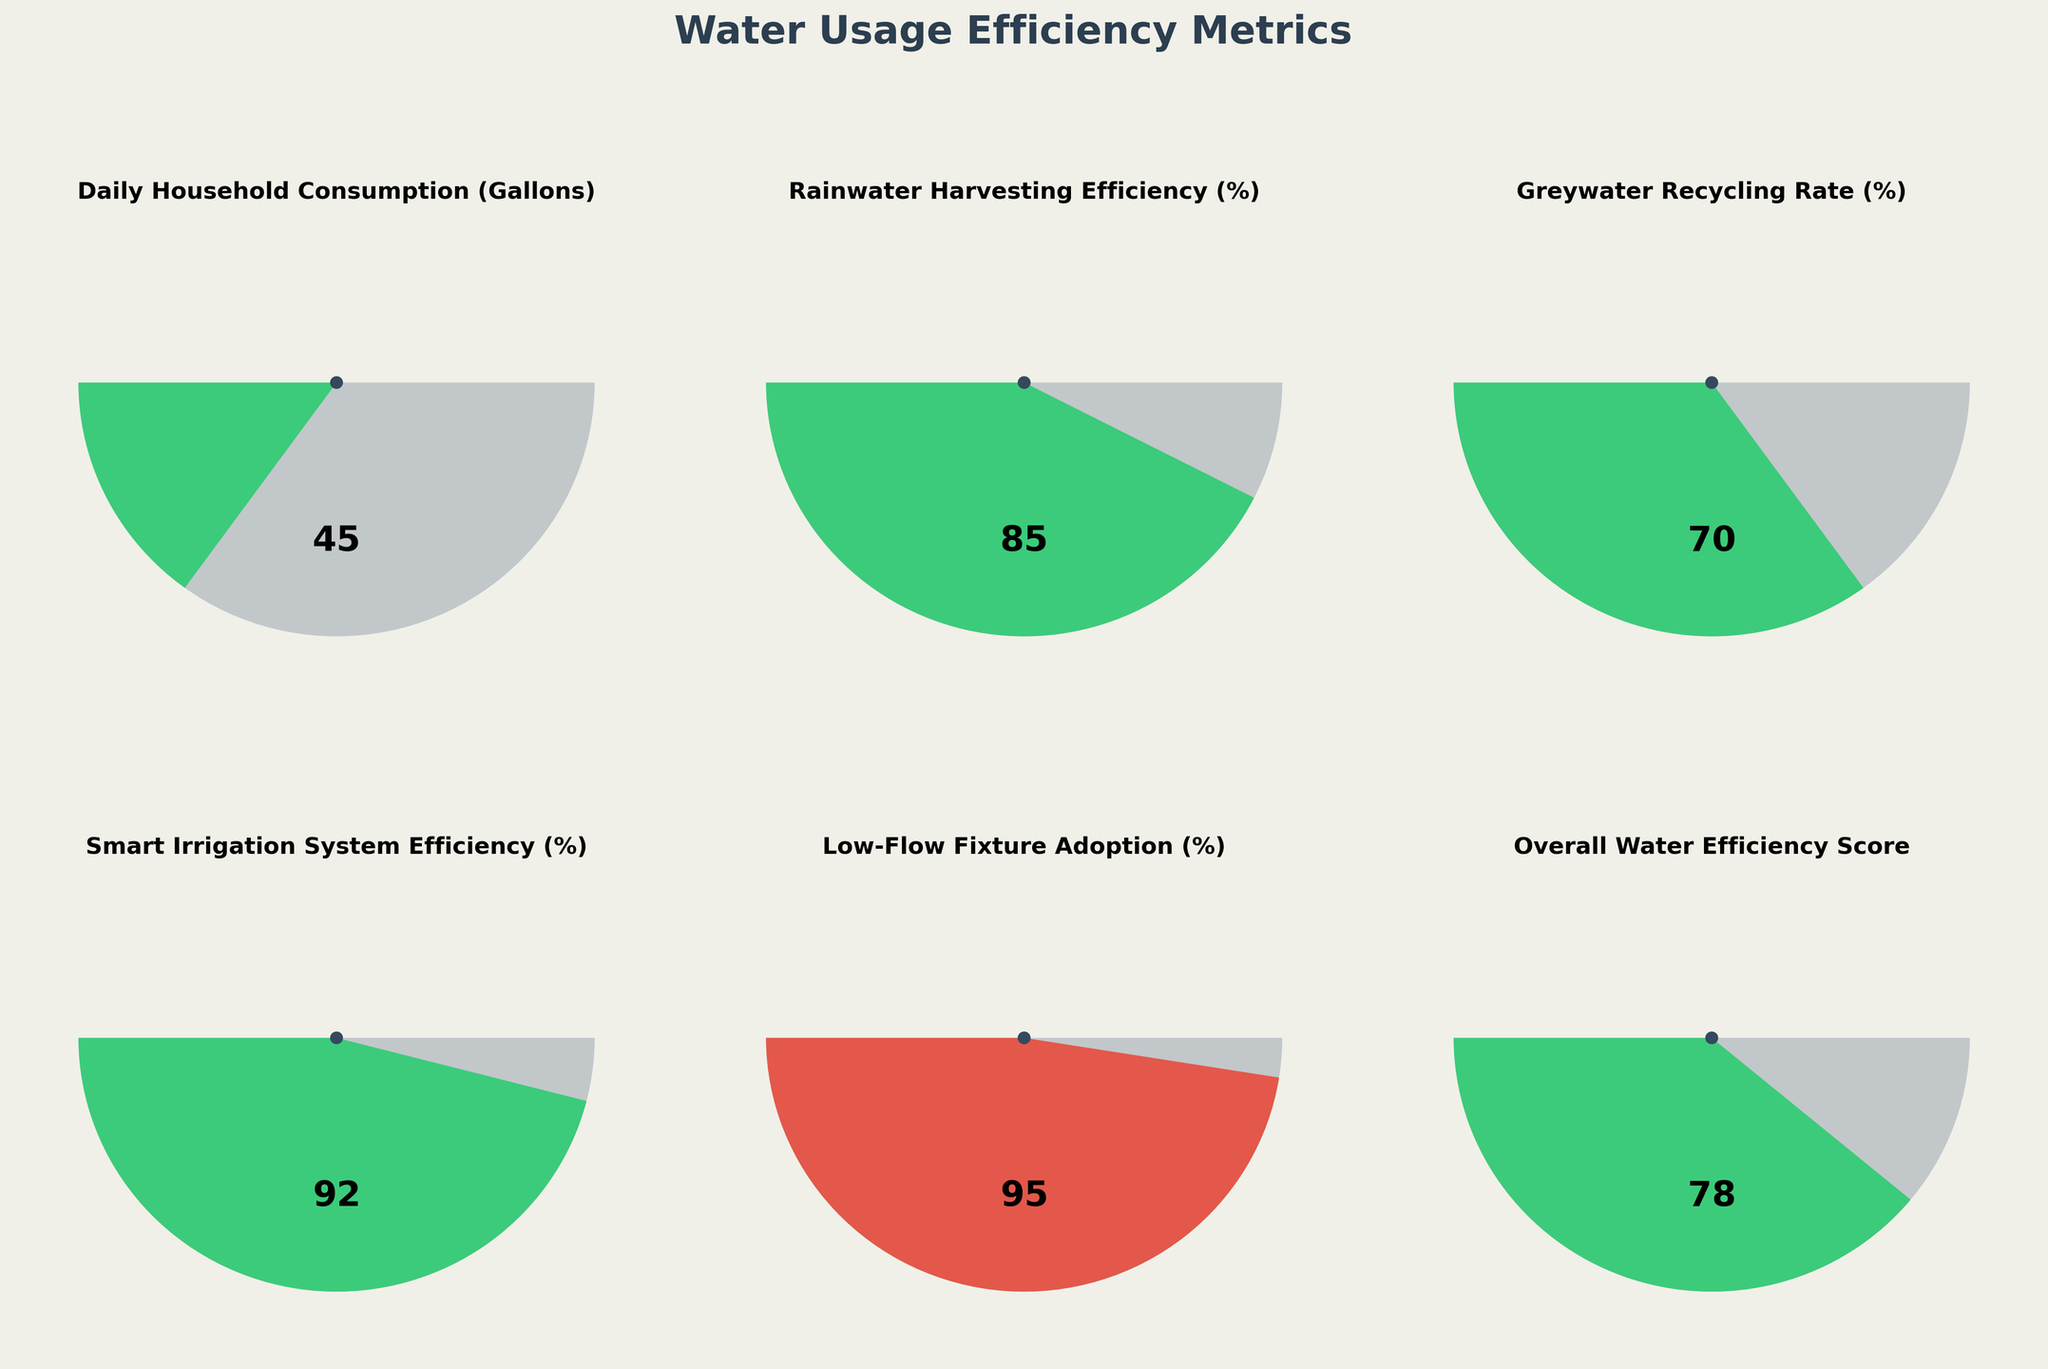What's the title of the figure? The title is mentioned at the top of the figure and reads "Water Usage Efficiency Metrics."
Answer: Water Usage Efficiency Metrics What is the current value for the daily household water consumption in gallons? The gauge for daily household water consumption is at the top-left of the figure, showing a current value of 45 gallons.
Answer: 45 gallons Does the smart irrigation system efficiency fall within the desired efficiency range? The smart irrigation system efficiency gauge shows a value of 92%, which is within the desired range of 75% to 95%, as indicated by the green color of the gauge.
Answer: Yes Which metric has the highest current value? Among all the gauges, Low-Flow Fixture Adoption shows the highest current value at 95%.
Answer: Low-Flow Fixture Adoption Compare the current value of greywater recycling rate to its low threshold. Is it above the threshold? The greywater recycling rate has a current value of 70%, which is above its low threshold of 50%.
Answer: Yes By how many percentage points is rainwater harvesting efficiency above its minimum value? Rainwater harvesting efficiency has a current value of 85% and a minimum value of 0%. The difference is 85% - 0% = 85 percentage points.
Answer: 85 percentage points Which of the efficiency metrics has the least deviation from its high threshold? Smart Irrigation System Efficiency has the smallest deviation from its high threshold; it is at 92%, just 3 percentage points below the high threshold of 95%.
Answer: Smart Irrigation System Efficiency What is the maximum value for the overall water efficiency score? The overall water efficiency score gauge shows that the maximum value is 100%.
Answer: 100% Which metrics fall within the specified low and high thresholds based on their current values? The following metrics fall within their specified low and high thresholds based on current values: Rainwater Harvesting Efficiency, Greywater Recycling Rate, Smart Irrigation System Efficiency, Low-Flow Fixture Adoption, and Overall Water Efficiency Score.
Answer: Rainwater Harvesting Efficiency, Greywater Recycling Rate, Smart Irrigation System Efficiency, Low-Flow Fixture Adoption, Overall Water Efficiency Score Is the daily household consumption metric in the desired efficiency range? The daily household consumption has a current value of 45 gallons, which is within the low threshold of 30 gallons and the high threshold of 80 gallons.
Answer: Yes 